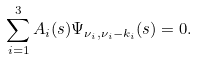<formula> <loc_0><loc_0><loc_500><loc_500>\sum _ { i = 1 } ^ { 3 } A _ { i } ( s ) \Psi _ { \nu _ { i } , \nu _ { i } - k _ { i } } ( s ) = 0 .</formula> 